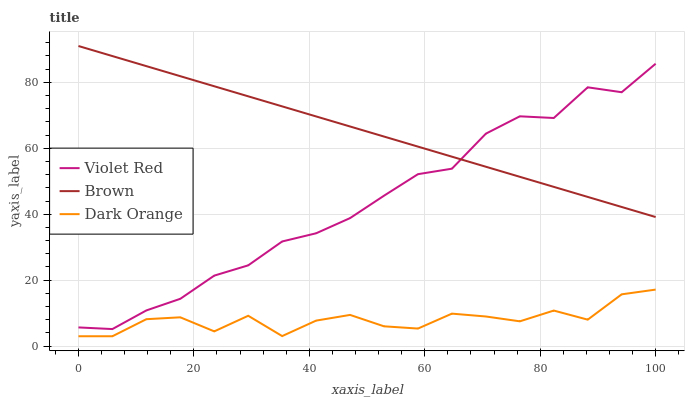Does Dark Orange have the minimum area under the curve?
Answer yes or no. Yes. Does Brown have the maximum area under the curve?
Answer yes or no. Yes. Does Violet Red have the minimum area under the curve?
Answer yes or no. No. Does Violet Red have the maximum area under the curve?
Answer yes or no. No. Is Brown the smoothest?
Answer yes or no. Yes. Is Dark Orange the roughest?
Answer yes or no. Yes. Is Violet Red the smoothest?
Answer yes or no. No. Is Violet Red the roughest?
Answer yes or no. No. Does Dark Orange have the lowest value?
Answer yes or no. Yes. Does Violet Red have the lowest value?
Answer yes or no. No. Does Brown have the highest value?
Answer yes or no. Yes. Does Violet Red have the highest value?
Answer yes or no. No. Is Dark Orange less than Brown?
Answer yes or no. Yes. Is Violet Red greater than Dark Orange?
Answer yes or no. Yes. Does Violet Red intersect Brown?
Answer yes or no. Yes. Is Violet Red less than Brown?
Answer yes or no. No. Is Violet Red greater than Brown?
Answer yes or no. No. Does Dark Orange intersect Brown?
Answer yes or no. No. 